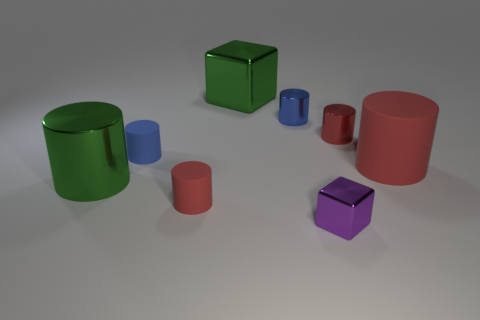Is the big cube the same color as the big metallic cylinder?
Your answer should be compact. Yes. What shape is the red object that is made of the same material as the big cube?
Your response must be concise. Cylinder. What is the color of the tiny object that is both in front of the small red metallic cylinder and behind the green cylinder?
Keep it short and to the point. Blue. How many cylinders are either large blue things or small metallic objects?
Give a very brief answer. 2. What number of red rubber cylinders are the same size as the green shiny cylinder?
Give a very brief answer. 1. What number of large red cylinders are left of the cube to the right of the tiny blue metallic object?
Ensure brevity in your answer.  0. There is a metallic thing that is in front of the small red metallic thing and to the left of the small purple thing; what size is it?
Provide a short and direct response. Large. Is the number of tiny blue metal cylinders greater than the number of cylinders?
Your answer should be very brief. No. Are there any small rubber objects that have the same color as the big rubber cylinder?
Your answer should be very brief. Yes. Does the block that is in front of the green metallic cube have the same size as the large green shiny cylinder?
Your response must be concise. No. 